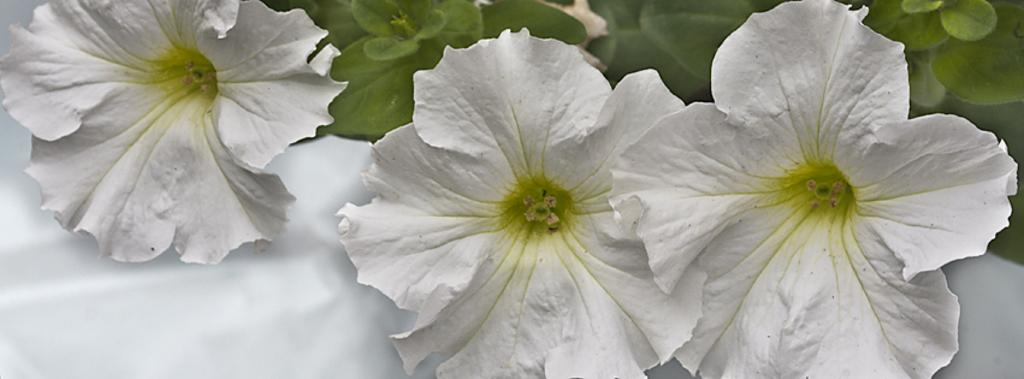What type of plants can be seen in the image? There are flowers in the image. What else can be seen in the background of the image? There are leaves visible in the background of the image. Can you tell me how the robin feels about the flowers in the image? There is no robin present in the image, so it is not possible to determine how a robin might feel about the flowers. 